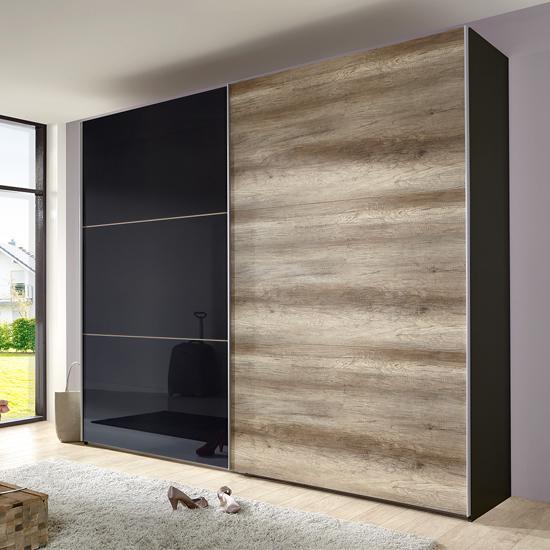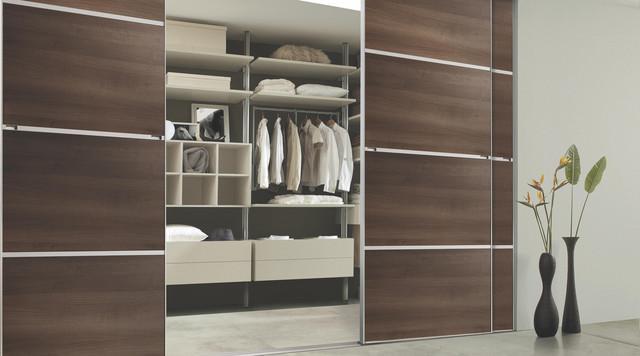The first image is the image on the left, the second image is the image on the right. Examine the images to the left and right. Is the description "Two wardrobes are each divided vertically down the middle to accommodate equal size solid doors." accurate? Answer yes or no. No. The first image is the image on the left, the second image is the image on the right. For the images displayed, is the sentence "There are four black panels on the wooden closet in the image on the right." factually correct? Answer yes or no. No. 